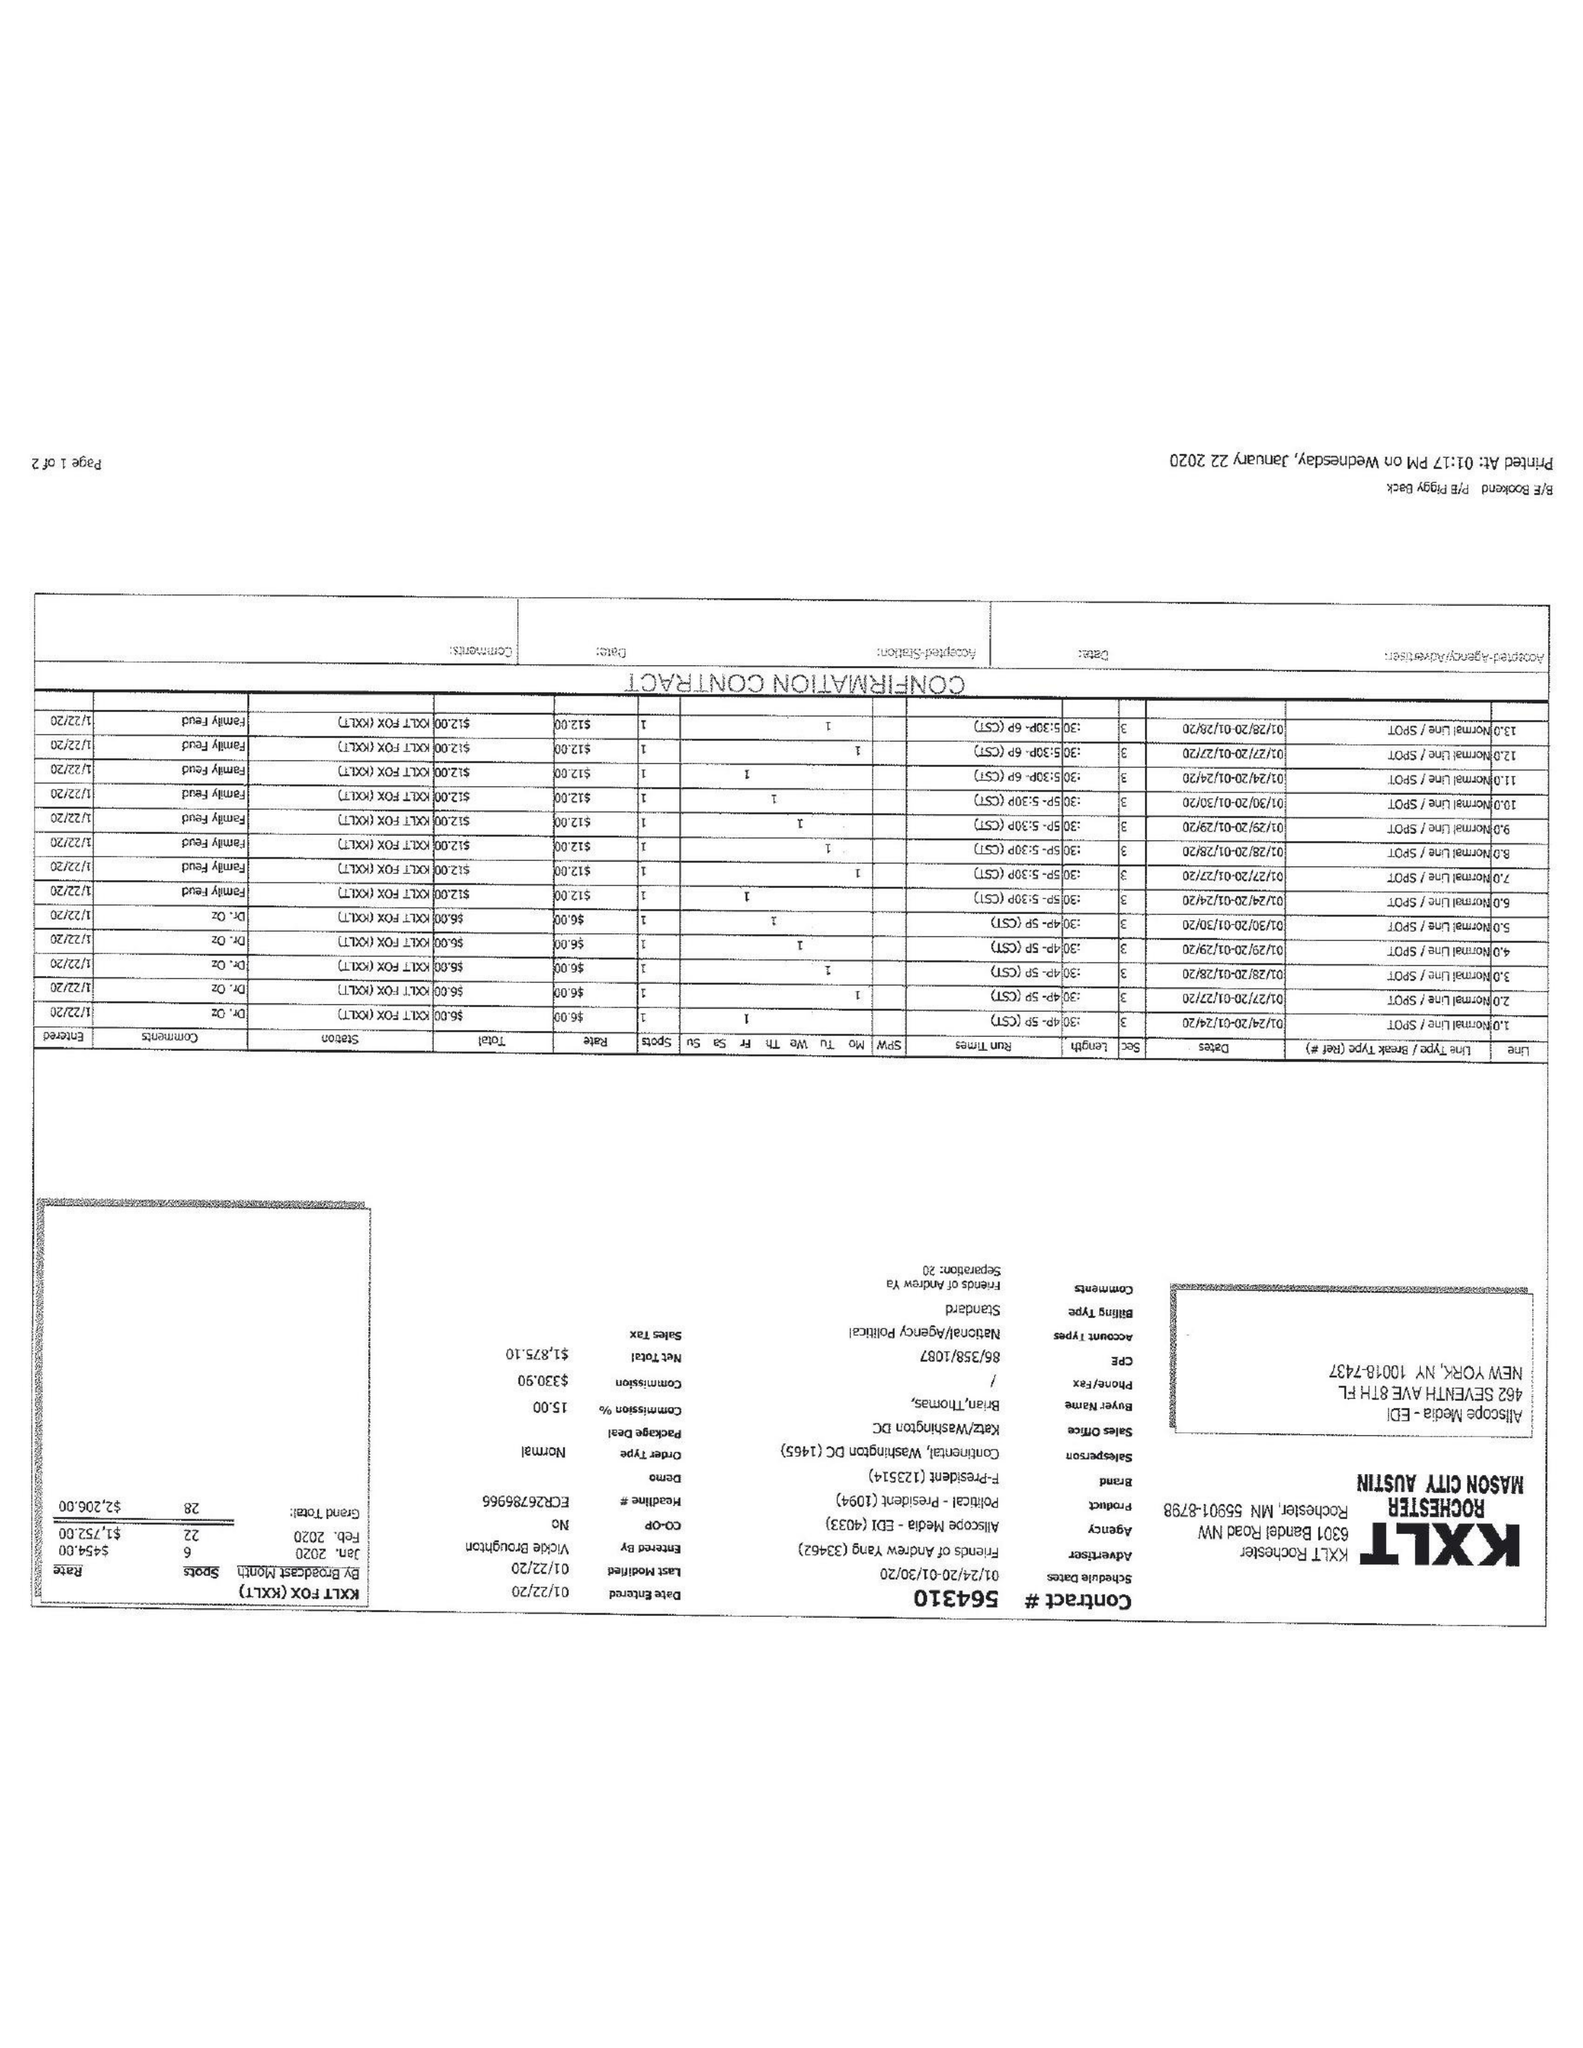What is the value for the gross_amount?
Answer the question using a single word or phrase. 2206.00 